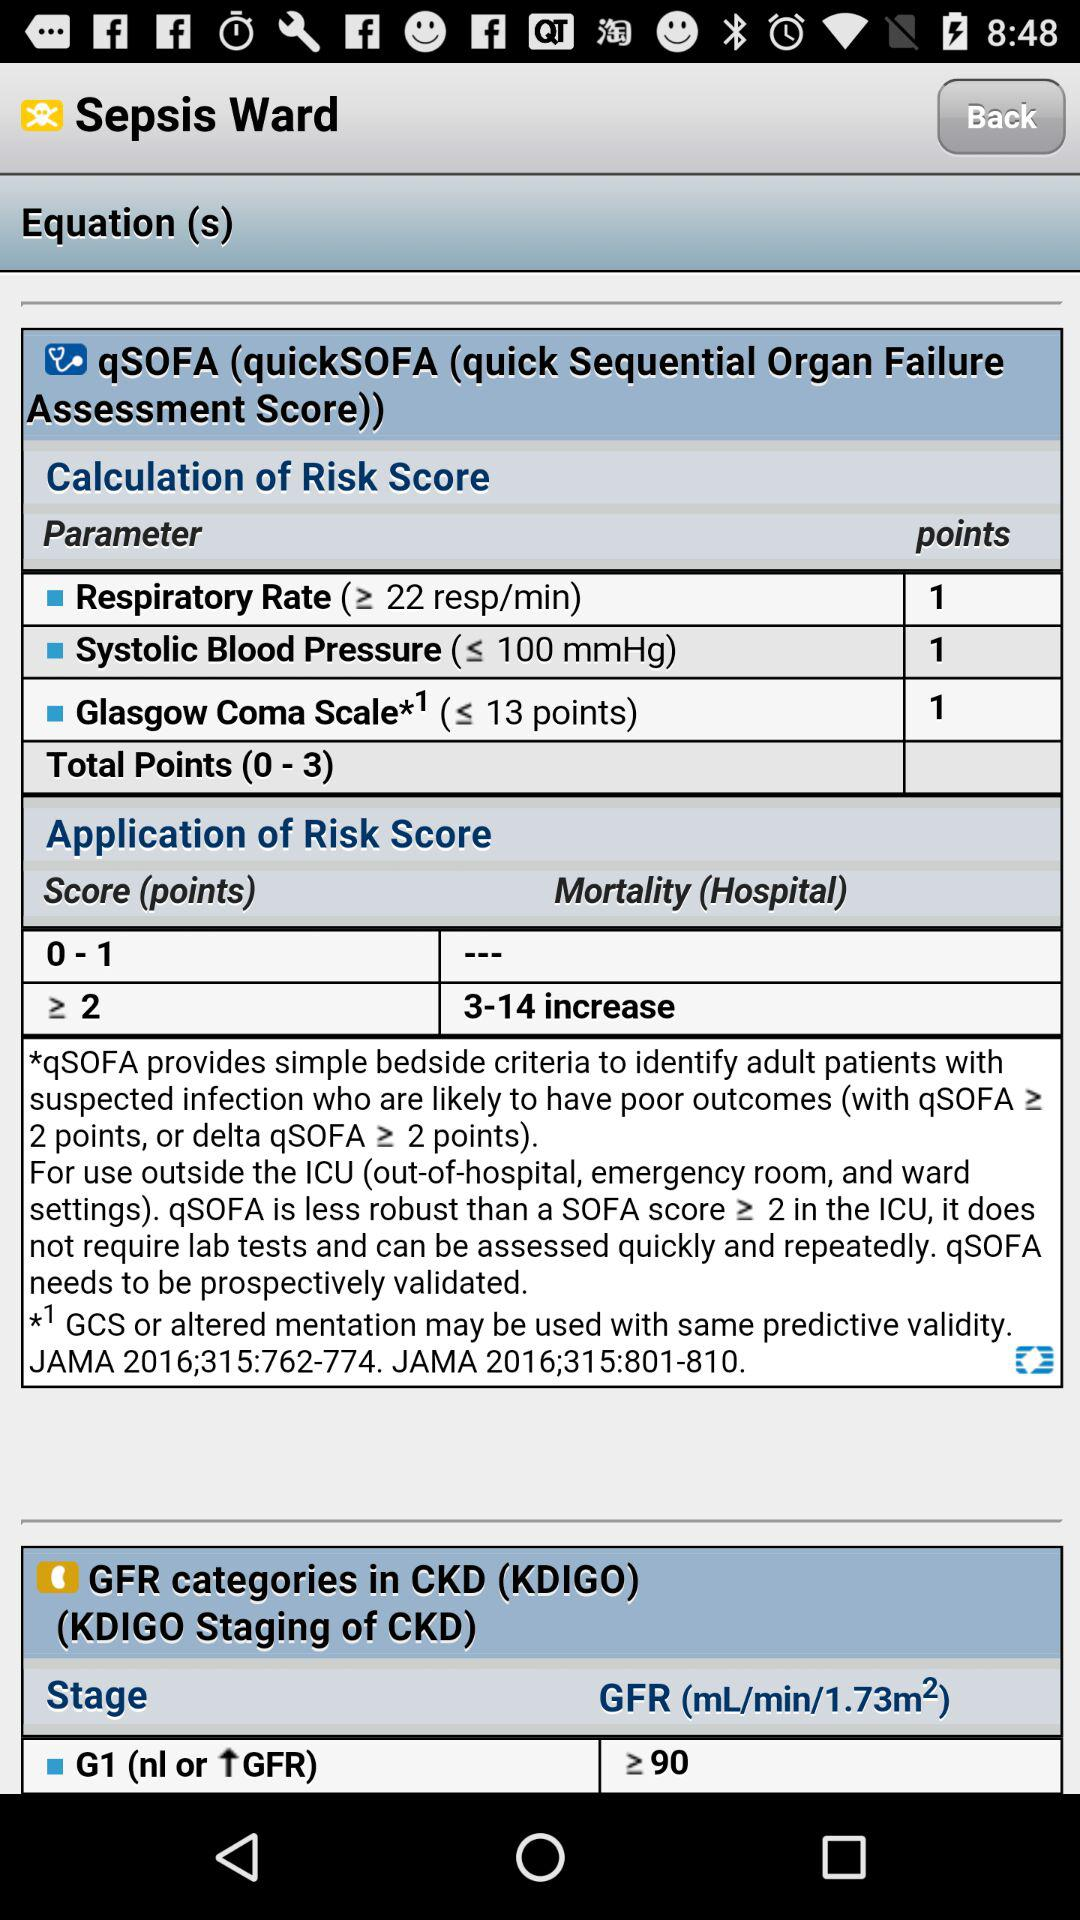What stage is given for GFR categories in CKD? The given stage is "G1 (nl or ⬆GFR)". 